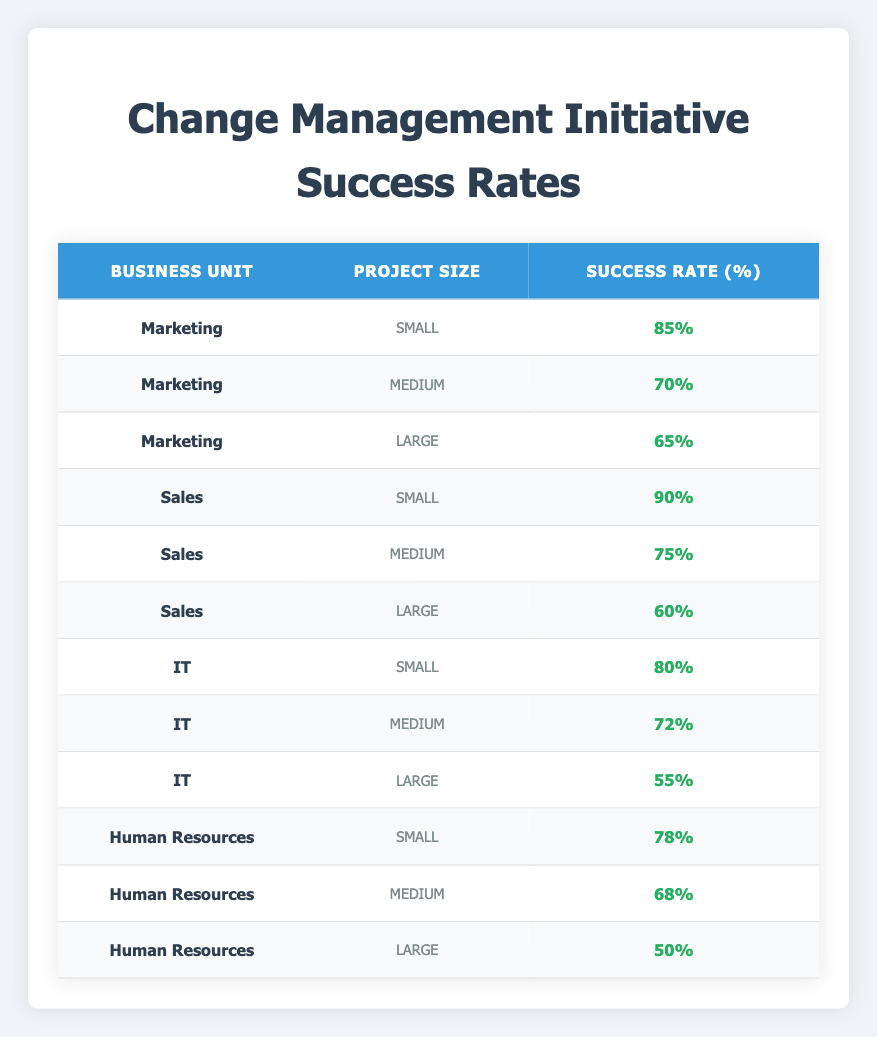What is the success rate for small projects in the Sales unit? From the table, under the Sales unit and small project size, the success rate is listed as 90%.
Answer: 90% What is the highest success rate among large projects? Looking through the large project sizes in all business units: Marketing has 65%, Sales has 60%, IT has 55%, and Human Resources has 50%. The highest is therefore 65% from Marketing.
Answer: 65% Is the success rate for medium-sized projects in IT less than 70%? The success rate for medium projects in IT is 72%. Since 72% is greater than 70%, the statement is false.
Answer: No Which business unit has the lowest success rate for small projects? The success rates for small projects are 85% for Marketing, 90% for Sales, 80% for IT, and 78% for Human Resources. The lowest is 78% for Human Resources.
Answer: Human Resources What is the average success rate for medium projects across all business units? The medium project success rates are 70% (Marketing), 75% (Sales), 72% (IT), and 68% (Human Resources). Adding these gives 70 + 75 + 72 + 68 = 285. Dividing by 4 gives the average as 285 / 4 = 71.25%.
Answer: 71.25% Does any business unit have a success rate of 50% for a large project? In the table, only Human Resources has a success rate of 50% for large projects. Therefore, the statement is true.
Answer: Yes Which project size has the highest success rate in the IT business unit? In the IT business unit, the success rates for small, medium, and large project sizes are 80%, 72%, and 55%, respectively. Thus, the highest is 80% for small projects.
Answer: Small What is the difference between the success rates of small and large projects in Marketing? In Marketing, the success rate for small projects is 85%, while for large projects, it is 65%. The difference is calculated as 85 - 65 = 20%.
Answer: 20% 